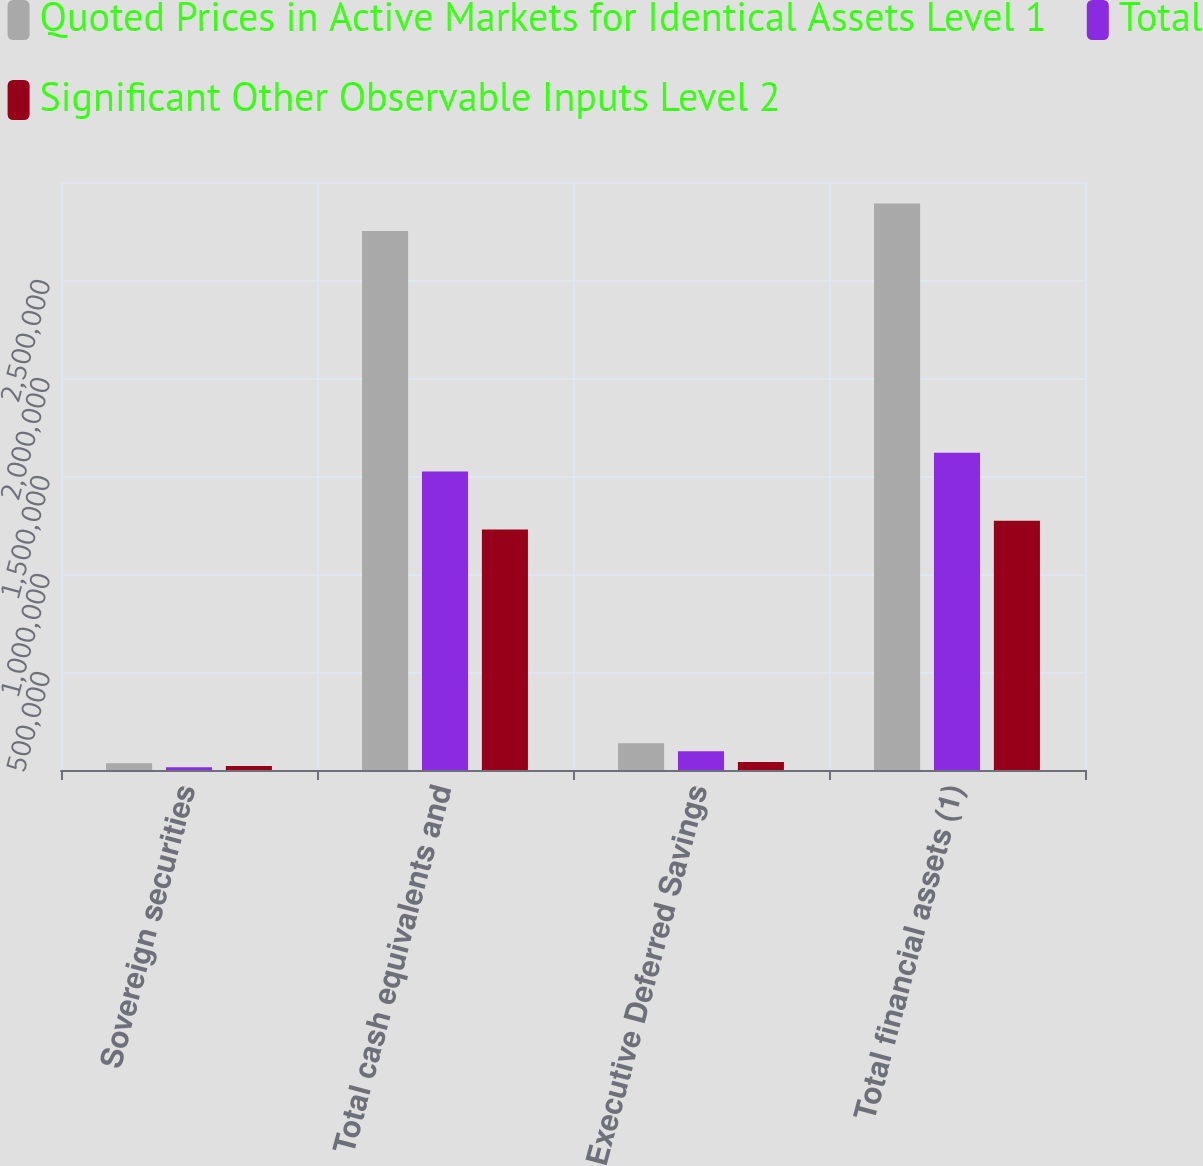Convert chart to OTSL. <chart><loc_0><loc_0><loc_500><loc_500><stacked_bar_chart><ecel><fcel>Sovereign securities<fcel>Total cash equivalents and<fcel>Executive Deferred Savings<fcel>Total financial assets (1)<nl><fcel>Quoted Prices in Active Markets for Identical Assets Level 1<fcel>33805<fcel>2.75001e+06<fcel>136461<fcel>2.89049e+06<nl><fcel>Total<fcel>13559<fcel>1.52298e+06<fcel>96180<fcel>1.61916e+06<nl><fcel>Significant Other Observable Inputs Level 2<fcel>20246<fcel>1.22703e+06<fcel>40281<fcel>1.27132e+06<nl></chart> 